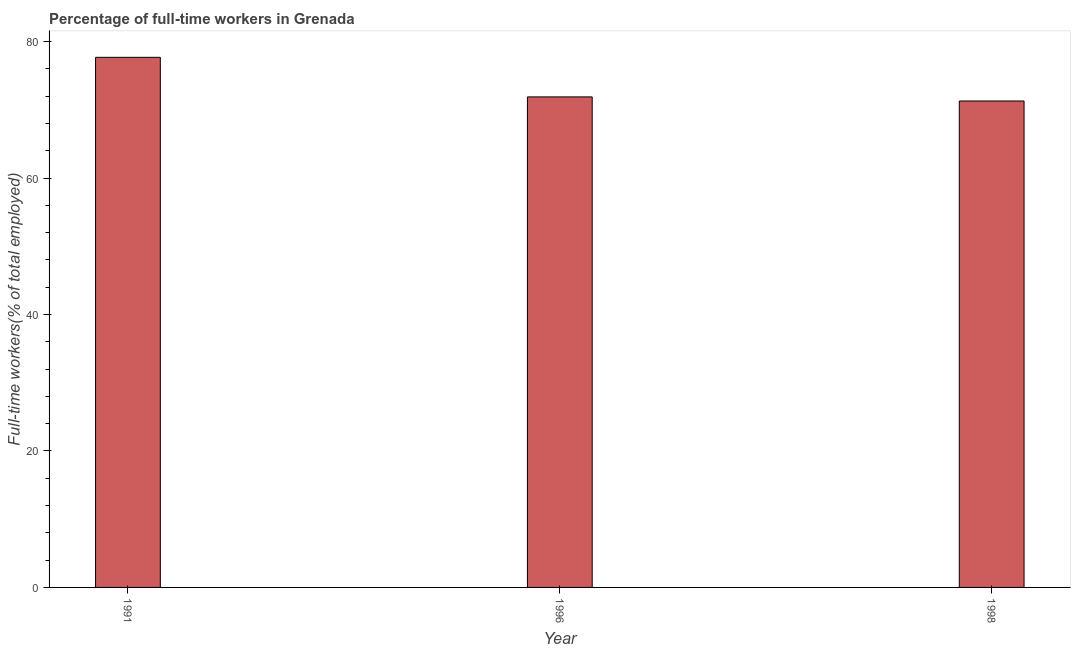Does the graph contain any zero values?
Provide a succinct answer. No. Does the graph contain grids?
Keep it short and to the point. No. What is the title of the graph?
Ensure brevity in your answer.  Percentage of full-time workers in Grenada. What is the label or title of the X-axis?
Your answer should be very brief. Year. What is the label or title of the Y-axis?
Keep it short and to the point. Full-time workers(% of total employed). What is the percentage of full-time workers in 1996?
Make the answer very short. 71.9. Across all years, what is the maximum percentage of full-time workers?
Your answer should be very brief. 77.7. Across all years, what is the minimum percentage of full-time workers?
Provide a succinct answer. 71.3. What is the sum of the percentage of full-time workers?
Your answer should be compact. 220.9. What is the difference between the percentage of full-time workers in 1991 and 1998?
Offer a very short reply. 6.4. What is the average percentage of full-time workers per year?
Give a very brief answer. 73.63. What is the median percentage of full-time workers?
Offer a terse response. 71.9. In how many years, is the percentage of full-time workers greater than 28 %?
Your answer should be very brief. 3. Do a majority of the years between 1998 and 1996 (inclusive) have percentage of full-time workers greater than 72 %?
Your answer should be very brief. No. Is the percentage of full-time workers in 1991 less than that in 1998?
Ensure brevity in your answer.  No. What is the difference between the highest and the second highest percentage of full-time workers?
Your answer should be compact. 5.8. Is the sum of the percentage of full-time workers in 1991 and 1996 greater than the maximum percentage of full-time workers across all years?
Make the answer very short. Yes. Are all the bars in the graph horizontal?
Your response must be concise. No. Are the values on the major ticks of Y-axis written in scientific E-notation?
Offer a very short reply. No. What is the Full-time workers(% of total employed) in 1991?
Your response must be concise. 77.7. What is the Full-time workers(% of total employed) in 1996?
Offer a very short reply. 71.9. What is the Full-time workers(% of total employed) in 1998?
Offer a very short reply. 71.3. What is the difference between the Full-time workers(% of total employed) in 1991 and 1998?
Ensure brevity in your answer.  6.4. What is the difference between the Full-time workers(% of total employed) in 1996 and 1998?
Give a very brief answer. 0.6. What is the ratio of the Full-time workers(% of total employed) in 1991 to that in 1996?
Make the answer very short. 1.08. What is the ratio of the Full-time workers(% of total employed) in 1991 to that in 1998?
Offer a terse response. 1.09. What is the ratio of the Full-time workers(% of total employed) in 1996 to that in 1998?
Give a very brief answer. 1.01. 